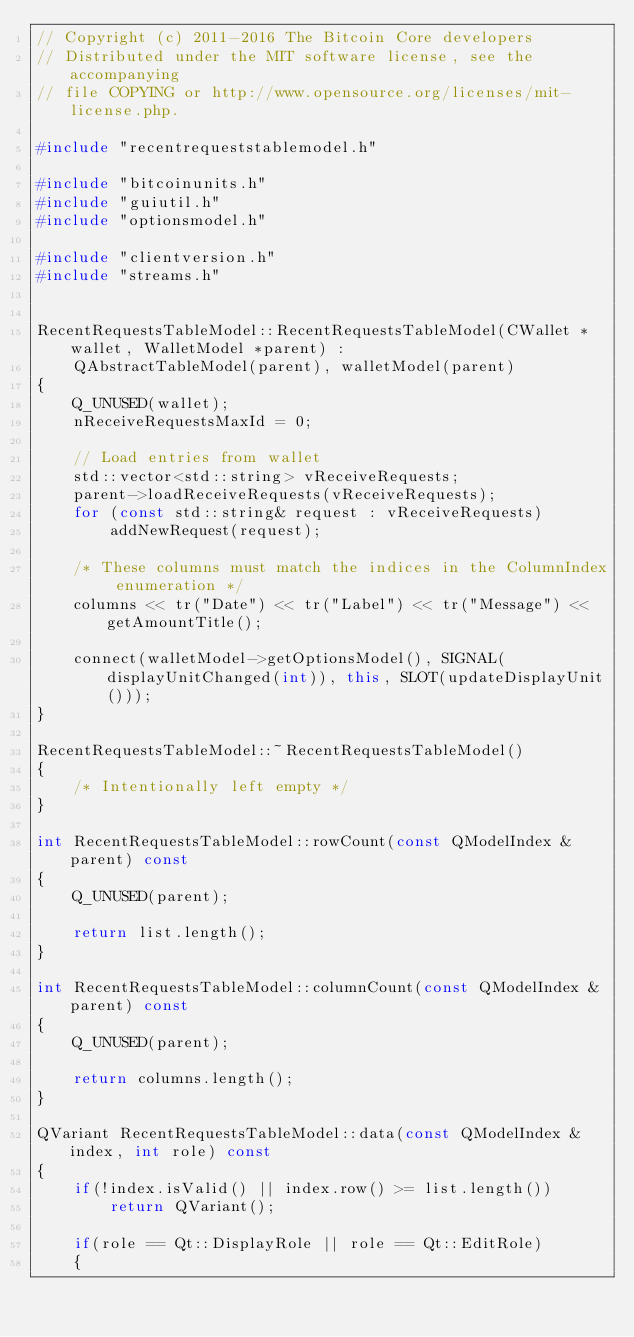Convert code to text. <code><loc_0><loc_0><loc_500><loc_500><_C++_>// Copyright (c) 2011-2016 The Bitcoin Core developers
// Distributed under the MIT software license, see the accompanying
// file COPYING or http://www.opensource.org/licenses/mit-license.php.

#include "recentrequeststablemodel.h"

#include "bitcoinunits.h"
#include "guiutil.h"
#include "optionsmodel.h"

#include "clientversion.h"
#include "streams.h"


RecentRequestsTableModel::RecentRequestsTableModel(CWallet *wallet, WalletModel *parent) :
    QAbstractTableModel(parent), walletModel(parent)
{
    Q_UNUSED(wallet);
    nReceiveRequestsMaxId = 0;

    // Load entries from wallet
    std::vector<std::string> vReceiveRequests;
    parent->loadReceiveRequests(vReceiveRequests);
    for (const std::string& request : vReceiveRequests)
        addNewRequest(request);

    /* These columns must match the indices in the ColumnIndex enumeration */
    columns << tr("Date") << tr("Label") << tr("Message") << getAmountTitle();

    connect(walletModel->getOptionsModel(), SIGNAL(displayUnitChanged(int)), this, SLOT(updateDisplayUnit()));
}

RecentRequestsTableModel::~RecentRequestsTableModel()
{
    /* Intentionally left empty */
}

int RecentRequestsTableModel::rowCount(const QModelIndex &parent) const
{
    Q_UNUSED(parent);

    return list.length();
}

int RecentRequestsTableModel::columnCount(const QModelIndex &parent) const
{
    Q_UNUSED(parent);

    return columns.length();
}

QVariant RecentRequestsTableModel::data(const QModelIndex &index, int role) const
{
    if(!index.isValid() || index.row() >= list.length())
        return QVariant();

    if(role == Qt::DisplayRole || role == Qt::EditRole)
    {</code> 